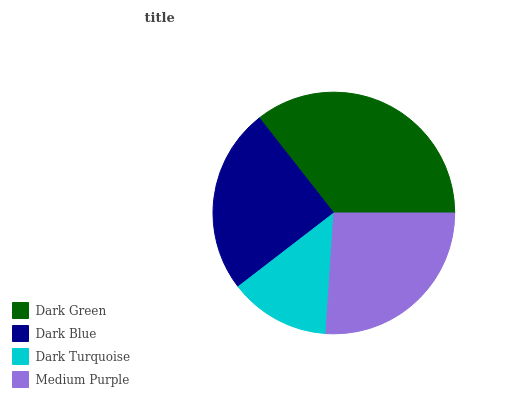Is Dark Turquoise the minimum?
Answer yes or no. Yes. Is Dark Green the maximum?
Answer yes or no. Yes. Is Dark Blue the minimum?
Answer yes or no. No. Is Dark Blue the maximum?
Answer yes or no. No. Is Dark Green greater than Dark Blue?
Answer yes or no. Yes. Is Dark Blue less than Dark Green?
Answer yes or no. Yes. Is Dark Blue greater than Dark Green?
Answer yes or no. No. Is Dark Green less than Dark Blue?
Answer yes or no. No. Is Medium Purple the high median?
Answer yes or no. Yes. Is Dark Blue the low median?
Answer yes or no. Yes. Is Dark Blue the high median?
Answer yes or no. No. Is Medium Purple the low median?
Answer yes or no. No. 